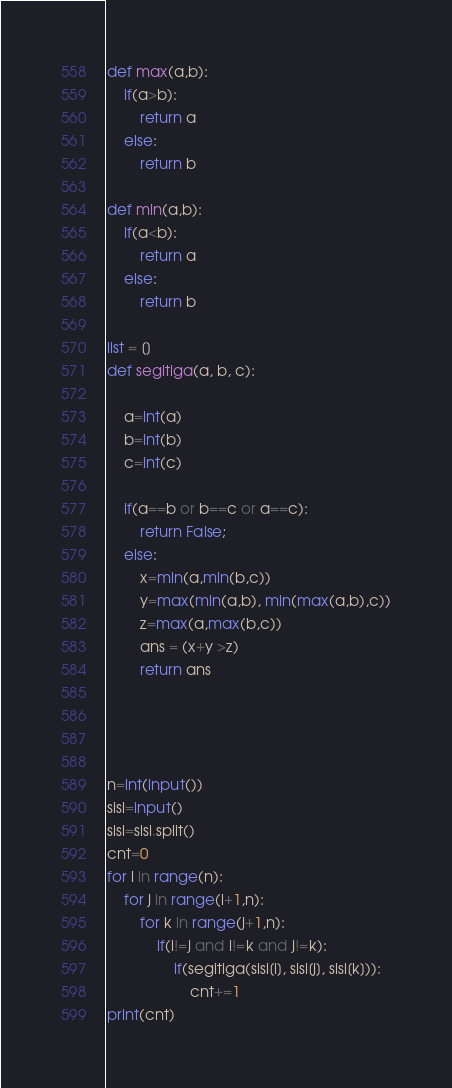Convert code to text. <code><loc_0><loc_0><loc_500><loc_500><_Python_>def max(a,b):
	if(a>b):
		return a
	else:
		return b

def min(a,b):
	if(a<b):
		return a
	else:
		return b

list = []
def segitiga(a, b, c):

	a=int(a)
	b=int(b)
	c=int(c)

	if(a==b or b==c or a==c):
		return False;
	else:
		x=min(a,min(b,c))
		y=max(min(a,b), min(max(a,b),c))
		z=max(a,max(b,c))
		ans = (x+y >z)
		return ans




n=int(input())
sisi=input()
sisi=sisi.split()
cnt=0
for i in range(n):
	for j in range(i+1,n):
		for k in range(j+1,n):
			if(i!=j and i!=k and j!=k):
				if(segitiga(sisi[i], sisi[j], sisi[k])):
					cnt+=1
print(cnt)</code> 